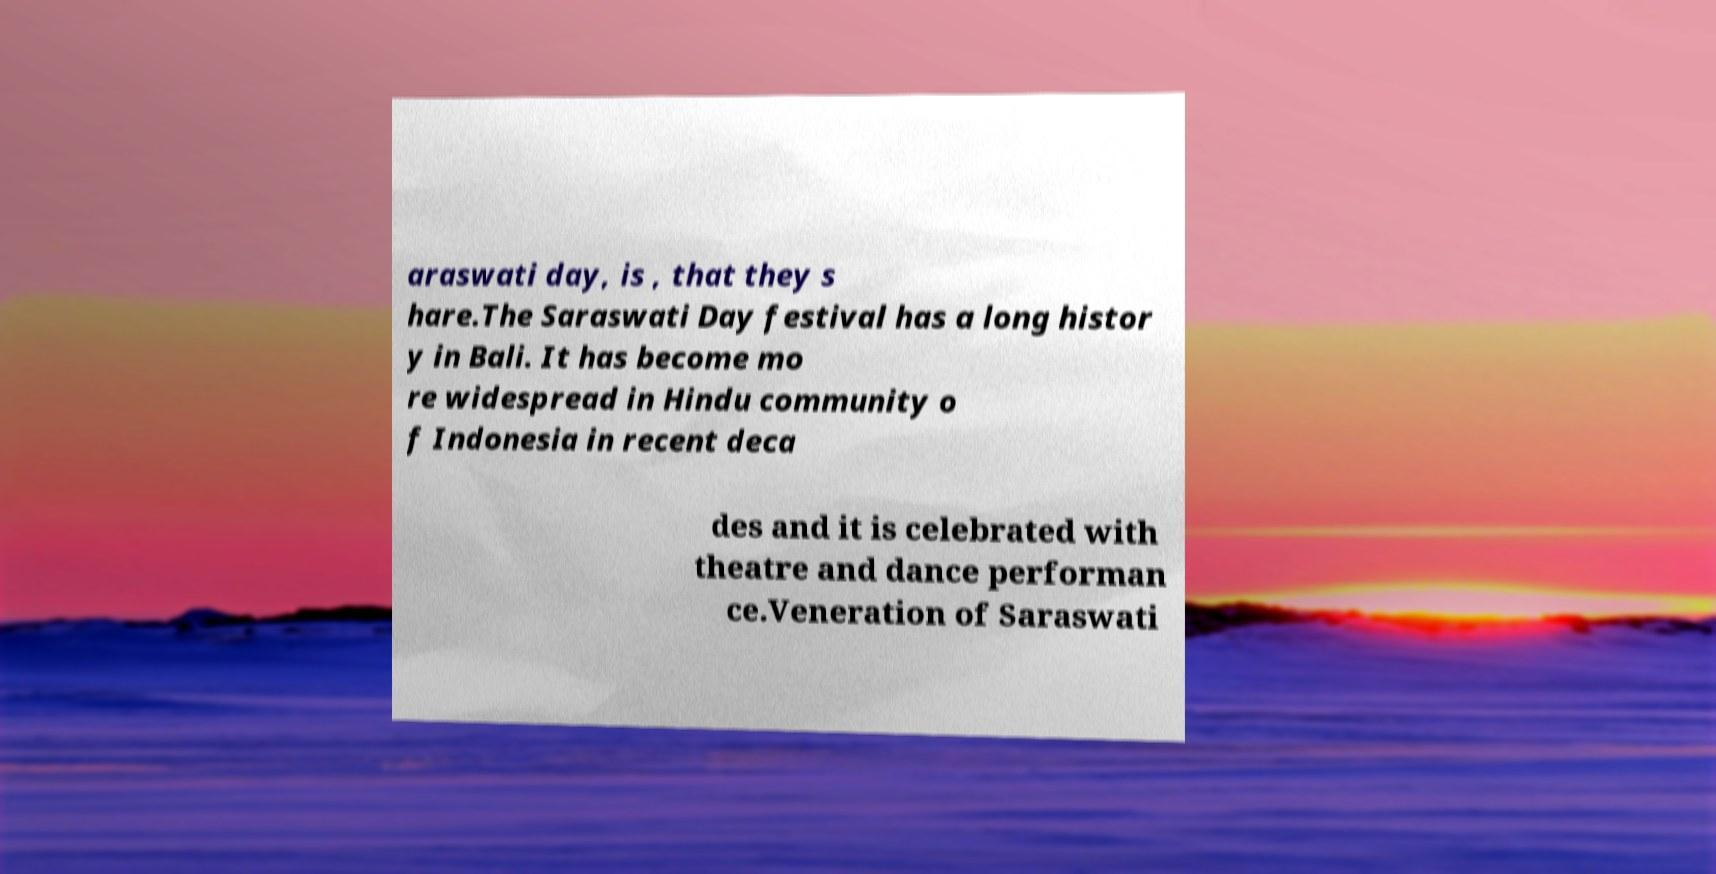Please read and relay the text visible in this image. What does it say? araswati day, is , that they s hare.The Saraswati Day festival has a long histor y in Bali. It has become mo re widespread in Hindu community o f Indonesia in recent deca des and it is celebrated with theatre and dance performan ce.Veneration of Saraswati 